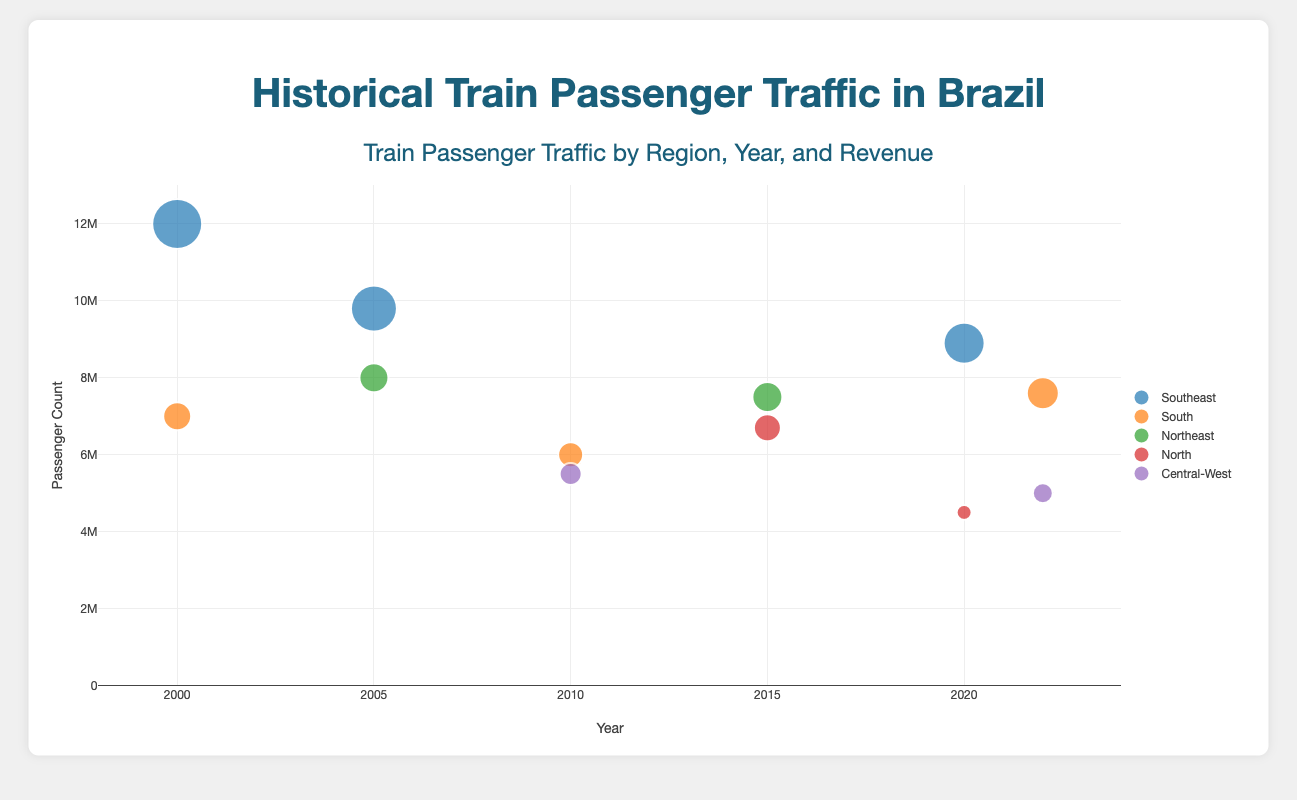Which region had the highest passenger count in 2000? From the graph, identify the Southeast region in 2000 and compare the passenger counts displayed. São Paulo, in the Southeast region, had the highest passenger count at 12,000,000.
Answer: Southeast Which city in the South region had the highest revenue in 2022? Locate the points corresponding to cities in the South region in 2022. Compare their revenues by observing the bubble size. Florianópolis had the highest revenue of R$3,200,000.
Answer: Florianópolis How did the passenger count in São Paulo change from 2000 to 2020? Observe the bubble corresponding to São Paulo in 2000 and compare its passenger count to 2020. São Paulo's data is only present in 2000, so there's no data to compare in 2020.
Answer: No data What is the range of years displayed on the x-axis? Look at the x-axis to find the start and end points of the year range. The x-axis covers the years from 1998 to 2024.
Answer: 1998-2024 Which region shows the largest increase in passenger count from 2005 to 2020? Identify the regions and track their passenger counts from 2005 to 2020. Compare the increases. The Southeast region shows the largest increase from 9,800,000 in Rio de Janeiro to 8,900,000 in Belo Horizonte by comparing their values.
Answer: Southeast What is the total passenger count for all regions in 2015? Sum the passenger counts for all regions in 2015: Recife (7,500,000) and Manaus (6,700,000).
Answer: 14,200,000 Which city had the smallest revenue in 2020? Look at the revenue texts of the cities in 2020. Belém had the smallest revenue at R$1,500,000.
Answer: Belém Compare the passenger counts of Curitiba and Florianópolis in 2010 and 2022, respectively. Which city had more passengers? Find and compare the passenger counts of Curitiba in 2010 and Florianópolis in 2022. Curitiba had 6,000,000 while Florianópolis had 7,600,000; Florianópolis had more passengers.
Answer: Florianópolis 